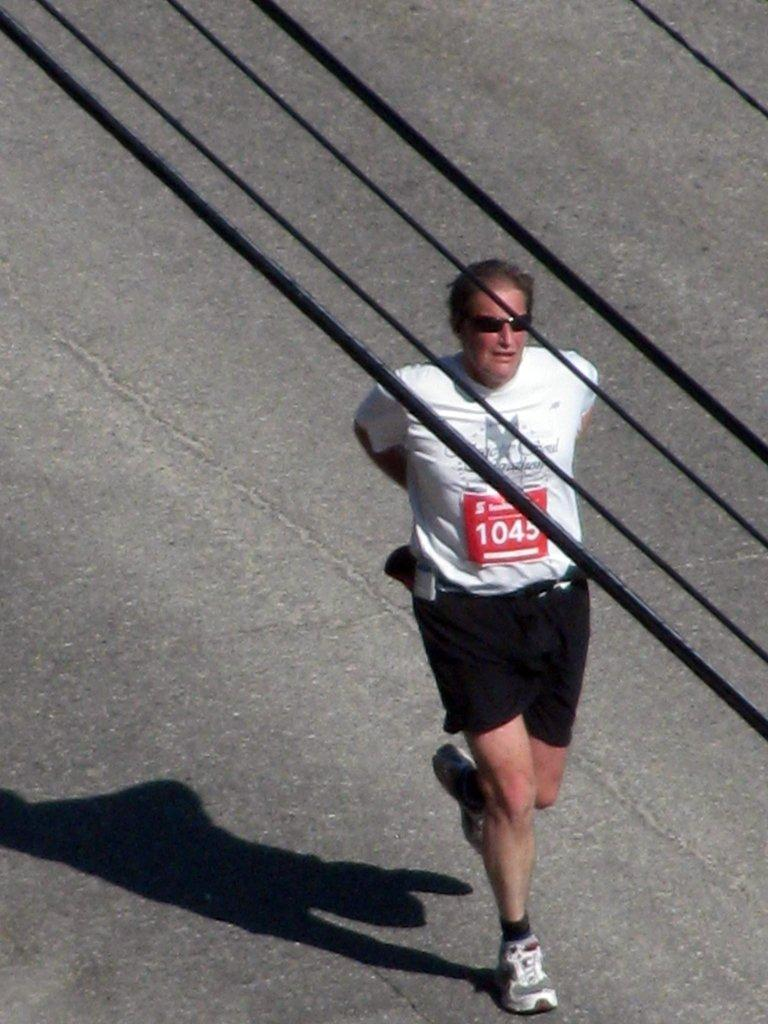What is the main subject of the image? There is a person walking on the road in the image. What else can be seen in the image besides the person? There are wires visible in the image. What is the color of the wires? The wires are black in color. Where is the prison located in the image? There is no prison present in the image. What type of root can be seen growing near the person in the image? There are no roots visible in the image. 